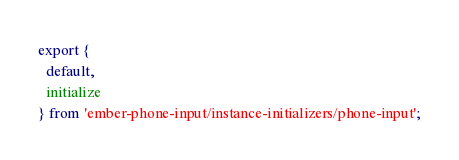<code> <loc_0><loc_0><loc_500><loc_500><_JavaScript_>export {
  default,
  initialize
} from 'ember-phone-input/instance-initializers/phone-input';
</code> 